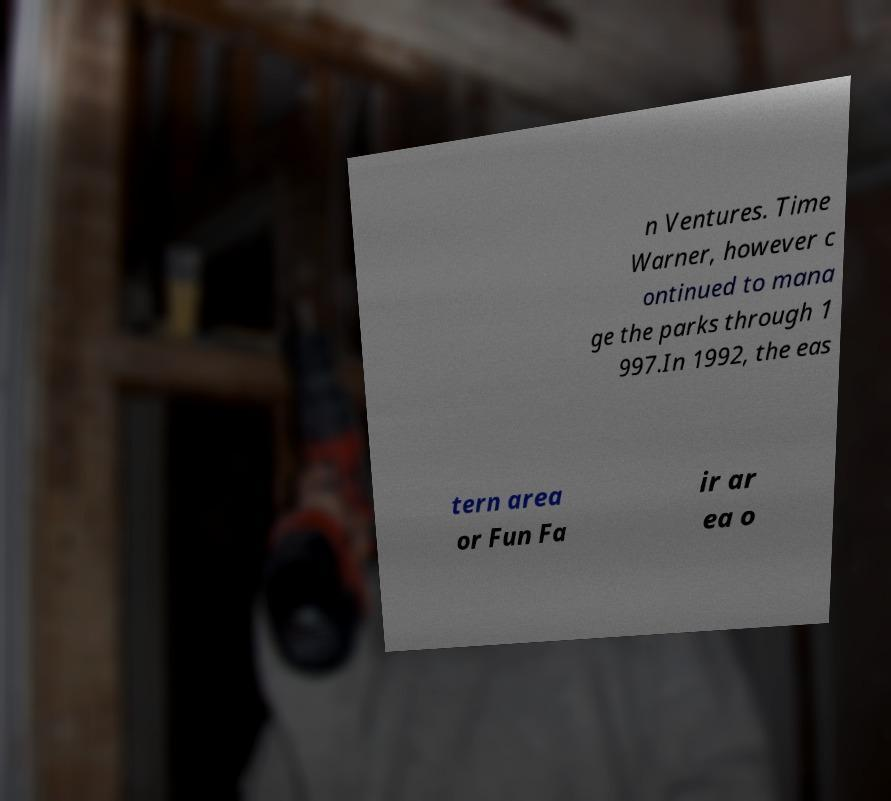Could you assist in decoding the text presented in this image and type it out clearly? n Ventures. Time Warner, however c ontinued to mana ge the parks through 1 997.In 1992, the eas tern area or Fun Fa ir ar ea o 